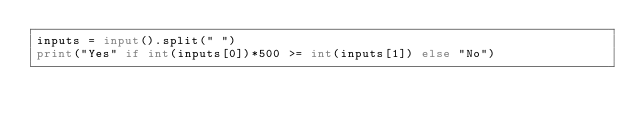<code> <loc_0><loc_0><loc_500><loc_500><_Python_>inputs = input().split(" ")
print("Yes" if int(inputs[0])*500 >= int(inputs[1]) else "No")
</code> 